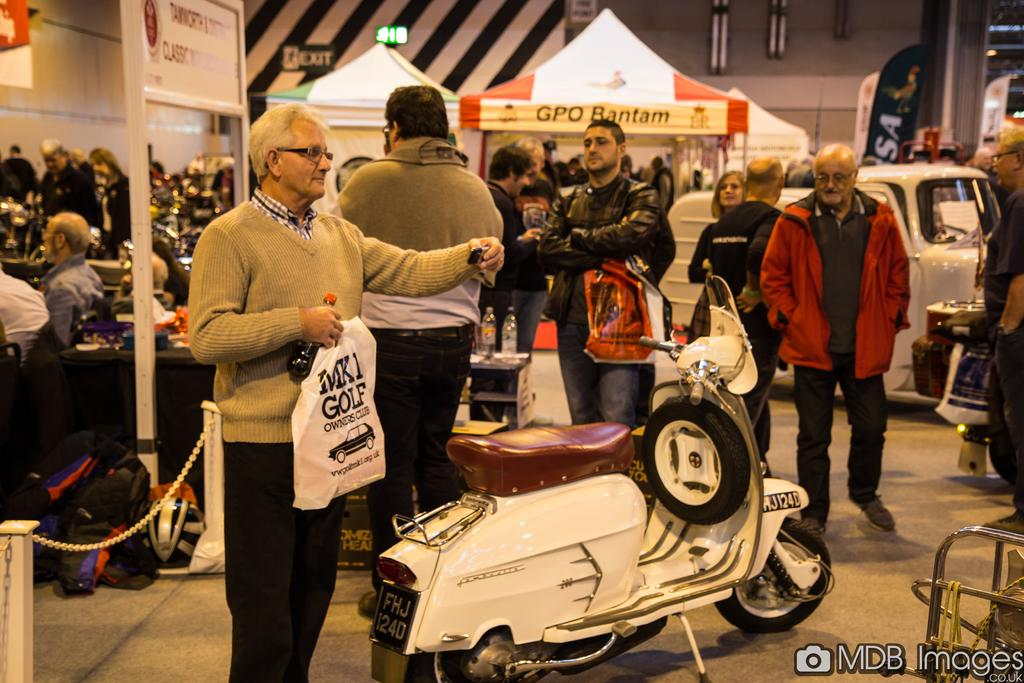What is the setting of the image? The image shows people in a hall. What else can be seen in the image besides the people? There are vehicles and tents in the image. What are some of the people doing in the image? Some people are sitting, while others are doing different activities. Is there any text in the image? Yes, there is a text in the bottom right corner of the image. How many kittens are playing with the wheel in the image? There are no kittens or wheels present in the image. What is the topic of the argument between the people in the image? There is no argument depicted in the image; people are engaged in various activities. 